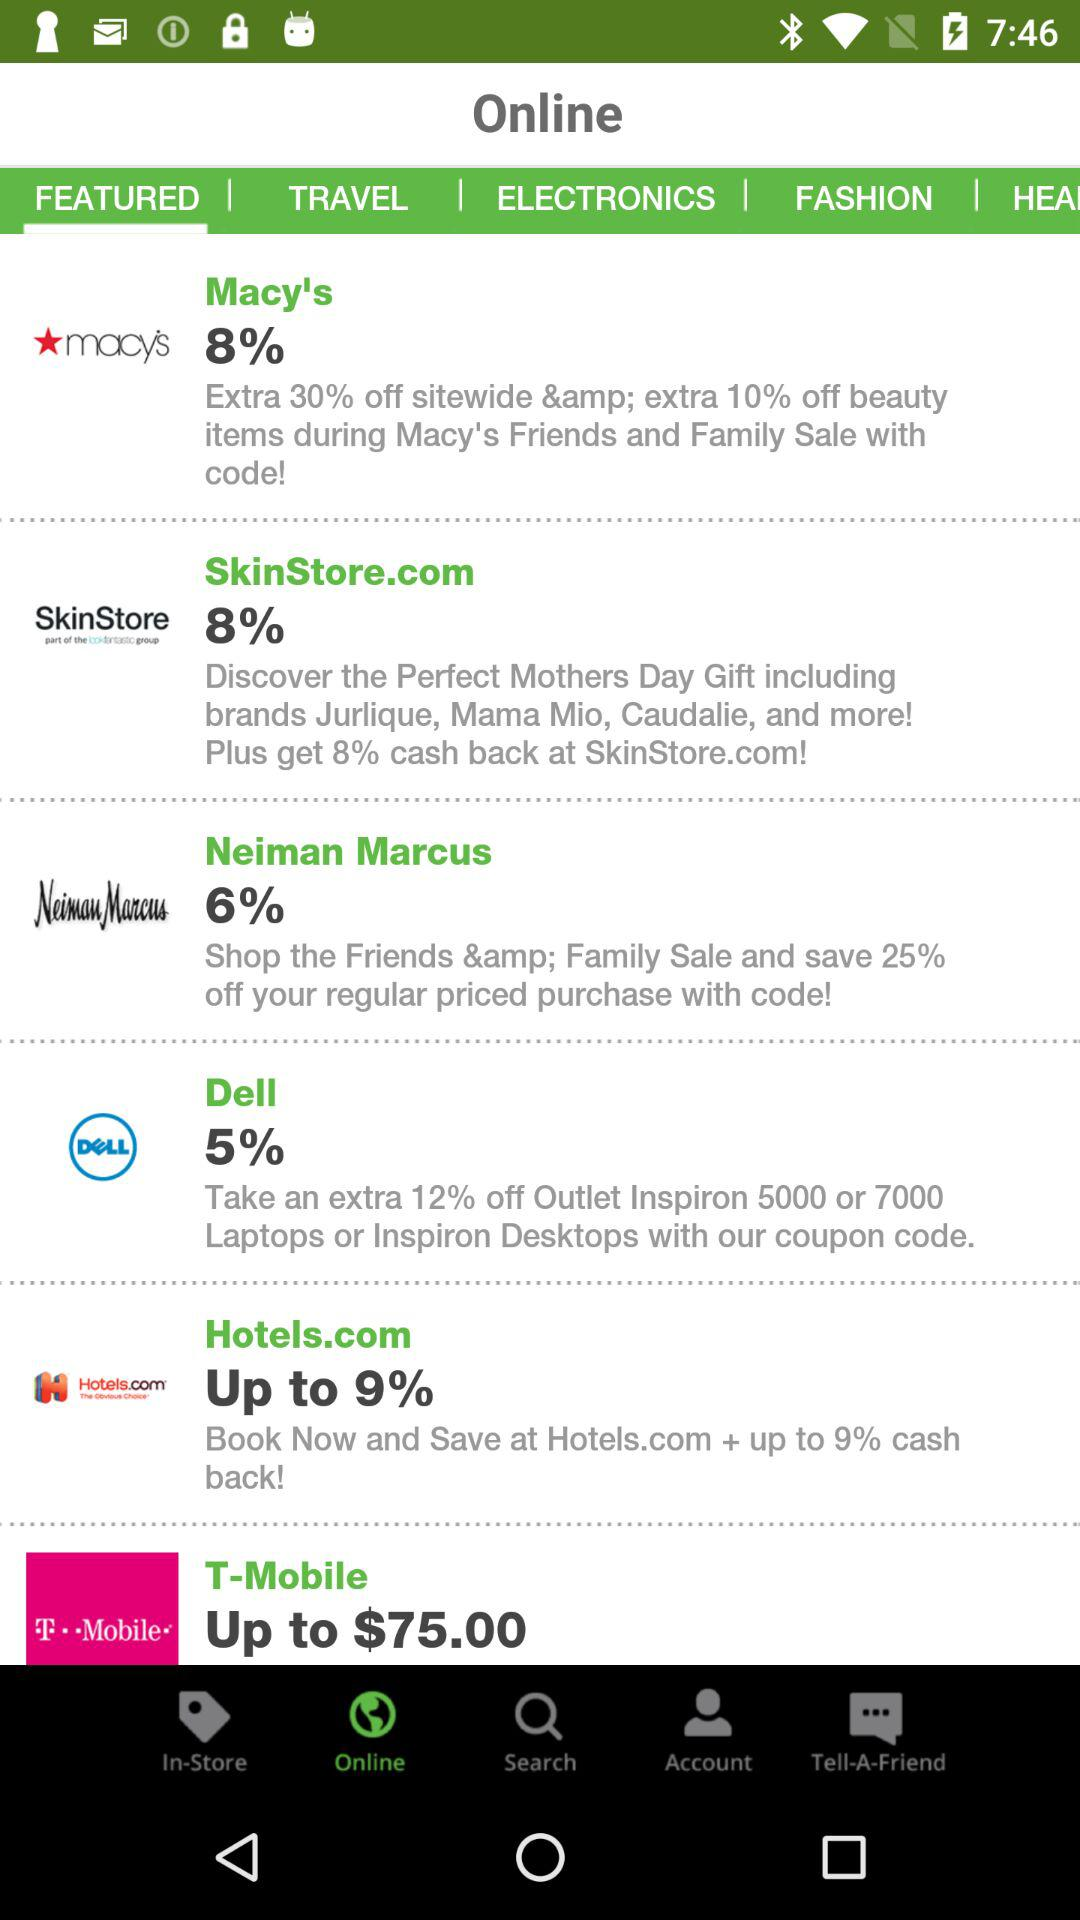Which company gives 25% off on the family sale? The company that gives 25% off on the family sale is "Neiman Marcus". 